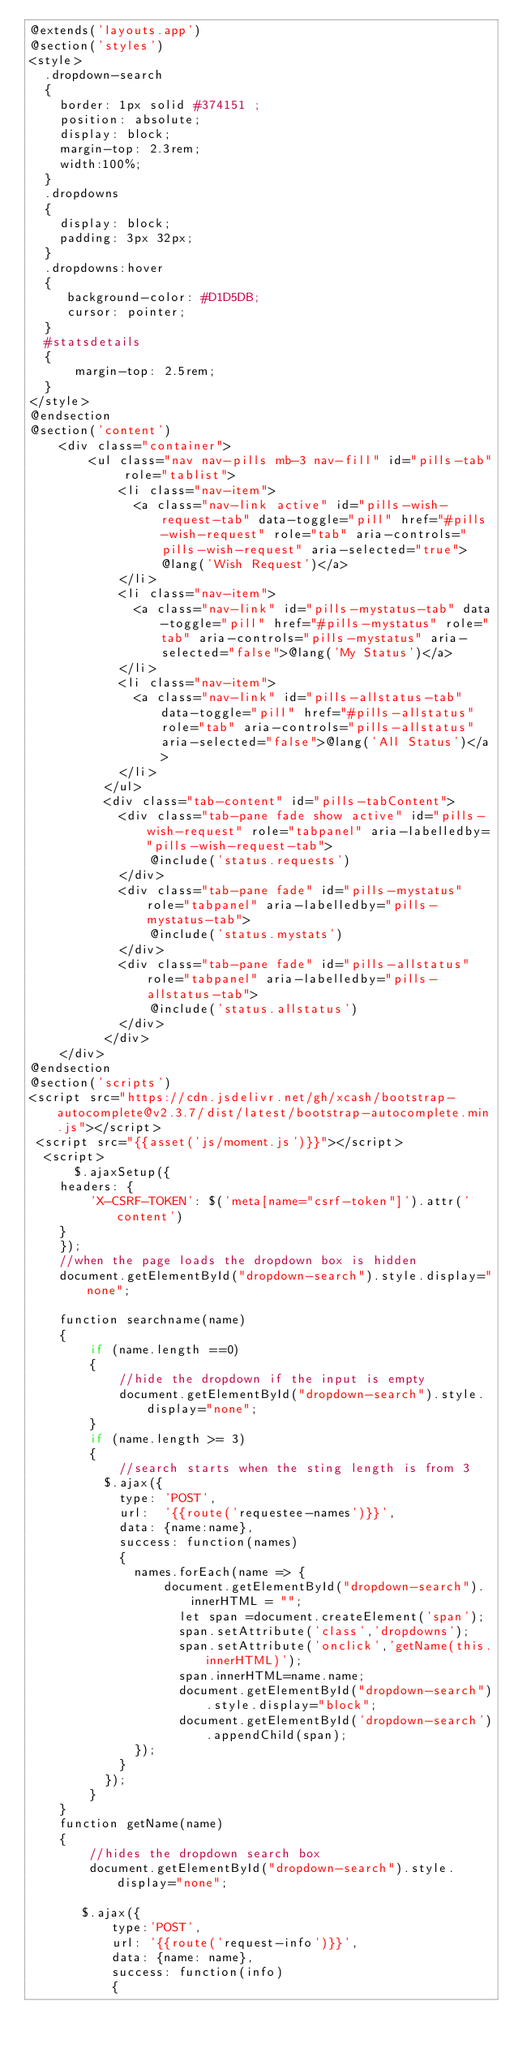<code> <loc_0><loc_0><loc_500><loc_500><_PHP_>@extends('layouts.app')
@section('styles')
<style>
  .dropdown-search
  {
    border: 1px solid #374151 ;
    position: absolute;
    display: block;
    margin-top: 2.3rem;
    width:100%;
  }
  .dropdowns
  {
    display: block;
    padding: 3px 32px;
  }
  .dropdowns:hover
  {
     background-color: #D1D5DB;
     cursor: pointer;
  }
  #statsdetails
  {
      margin-top: 2.5rem;
  }
</style>
@endsection
@section('content')
    <div class="container">
        <ul class="nav nav-pills mb-3 nav-fill" id="pills-tab" role="tablist">
            <li class="nav-item">
              <a class="nav-link active" id="pills-wish-request-tab" data-toggle="pill" href="#pills-wish-request" role="tab" aria-controls="pills-wish-request" aria-selected="true">@lang('Wish Request')</a>
            </li>
            <li class="nav-item">
              <a class="nav-link" id="pills-mystatus-tab" data-toggle="pill" href="#pills-mystatus" role="tab" aria-controls="pills-mystatus" aria-selected="false">@lang('My Status')</a>
            </li>
            <li class="nav-item">
              <a class="nav-link" id="pills-allstatus-tab" data-toggle="pill" href="#pills-allstatus" role="tab" aria-controls="pills-allstatus" aria-selected="false">@lang('All Status')</a>
            </li>
          </ul>
          <div class="tab-content" id="pills-tabContent">
            <div class="tab-pane fade show active" id="pills-wish-request" role="tabpanel" aria-labelledby="pills-wish-request-tab">
                @include('status.requests')
            </div>
            <div class="tab-pane fade" id="pills-mystatus" role="tabpanel" aria-labelledby="pills-mystatus-tab">
                @include('status.mystats')
            </div>
            <div class="tab-pane fade" id="pills-allstatus" role="tabpanel" aria-labelledby="pills-allstatus-tab">
                @include('status.allstatus')
            </div>
          </div>
    </div>
@endsection
@section('scripts')
<script src="https://cdn.jsdelivr.net/gh/xcash/bootstrap-autocomplete@v2.3.7/dist/latest/bootstrap-autocomplete.min.js"></script>
 <script src="{{asset('js/moment.js')}}"></script>
  <script>
      $.ajaxSetup({
    headers: {
        'X-CSRF-TOKEN': $('meta[name="csrf-token"]').attr('content')
    }
    });
    //when the page loads the dropdown box is hidden
    document.getElementById("dropdown-search").style.display="none";

    function searchname(name)
    {
        if (name.length ==0)
        {
            //hide the dropdown if the input is empty
            document.getElementById("dropdown-search").style.display="none";
        }
        if (name.length >= 3)
        {
            //search starts when the sting length is from 3
          $.ajax({
            type: 'POST',
            url:  '{{route('requestee-names')}}',
            data: {name:name},
            success: function(names)
            {
              names.forEach(name => {
                  document.getElementById("dropdown-search").innerHTML = "";
                    let span =document.createElement('span');
                    span.setAttribute('class','dropdowns');
                    span.setAttribute('onclick','getName(this.innerHTML)');
                    span.innerHTML=name.name;
                    document.getElementById("dropdown-search").style.display="block";
                    document.getElementById('dropdown-search').appendChild(span);
              });
            }
          });
        }
    }
    function getName(name)
    {
        //hides the dropdown search box
        document.getElementById("dropdown-search").style.display="none";

       $.ajax({
           type:'POST',
           url: '{{route('request-info')}}',
           data: {name: name},
           success: function(info)
           {</code> 